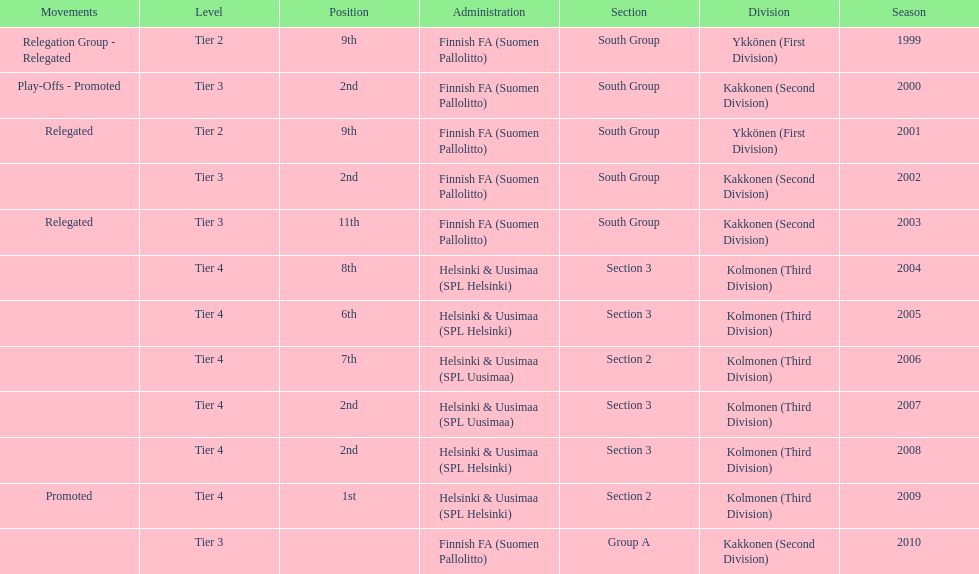Which group did they mostly belong to, segment 3 or 2? 3. 